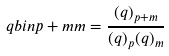<formula> <loc_0><loc_0><loc_500><loc_500>\ q b i n { p + m } { m } = \frac { ( q ) _ { p + m } } { ( q ) _ { p } ( q ) _ { m } }</formula> 